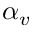<formula> <loc_0><loc_0><loc_500><loc_500>\alpha _ { v }</formula> 